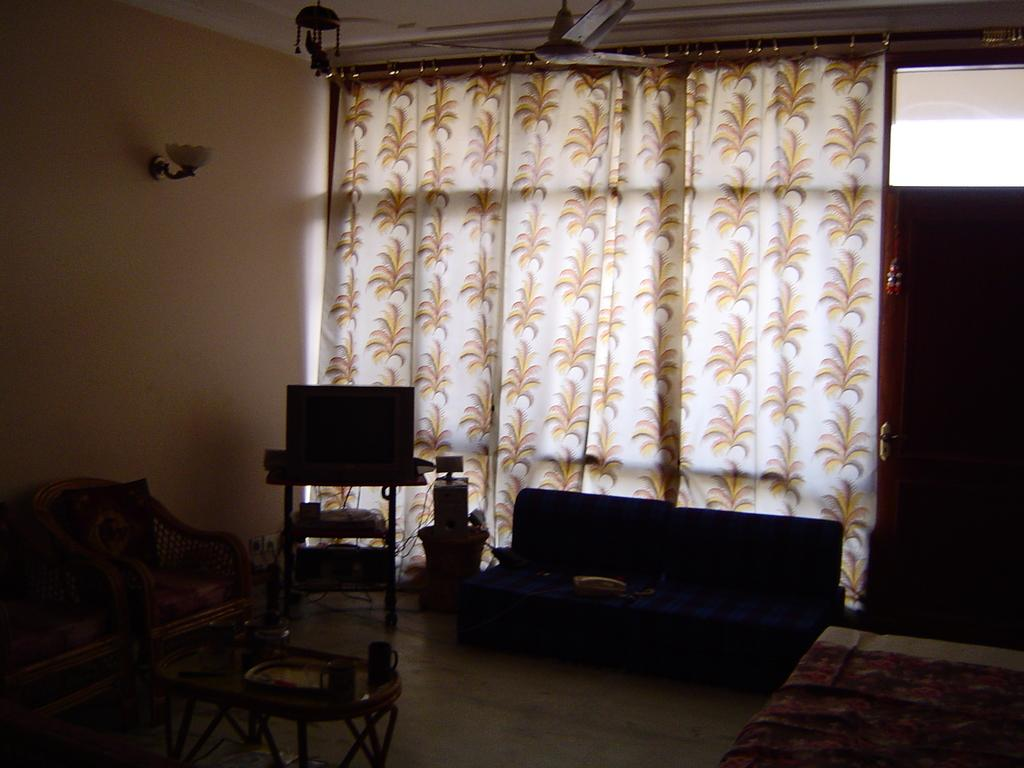What type of furniture is present in the image? There are chairs and a sofa in the image. What type of window treatment is visible in the image? There are curtains in the image. What type of surface is present in the image for placing objects? There is a table in the image. How many cups are on the table in the image? There are two cups on the table. Can you see any men or beams in the image? There are no men or beams present in the image. What type of waves can be seen in the image? There are no waves present in the image. 